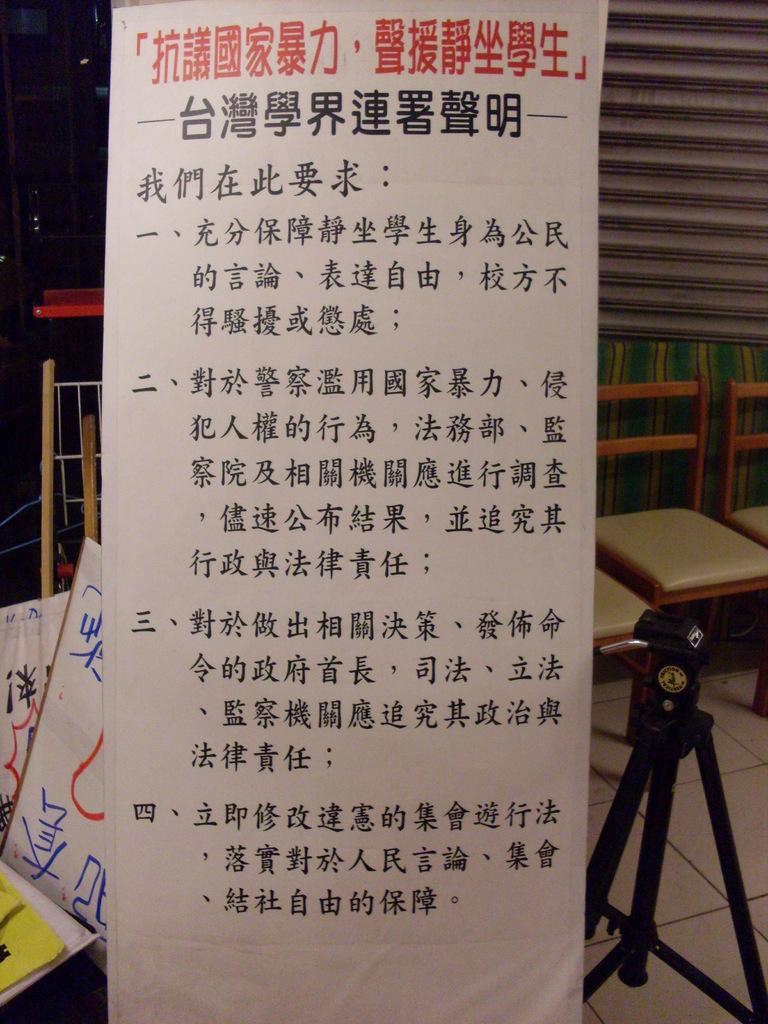Please provide a concise description of this image. In the foreground of this image, there is a banner, few banners on the left, few chairs on the right and also a stand on the floor. In the background, it seems like there is a shutter. 